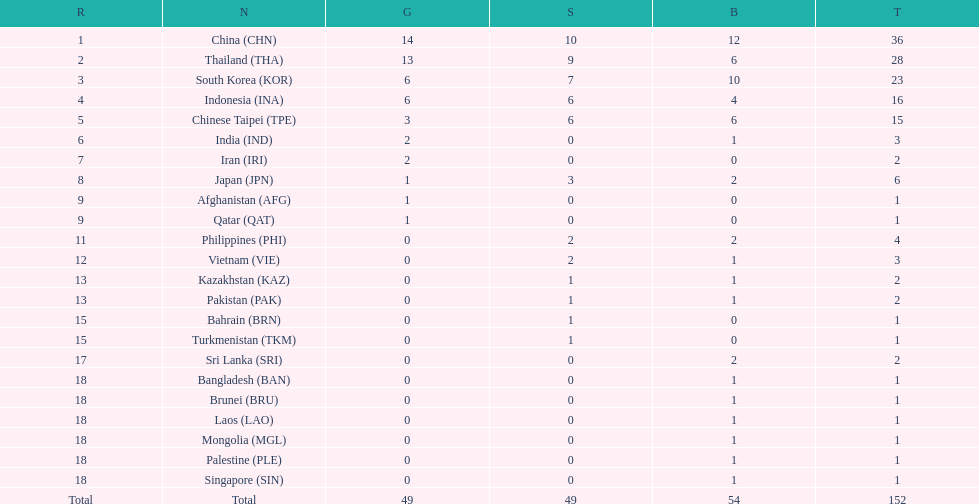How many total gold medal have been given? 49. 